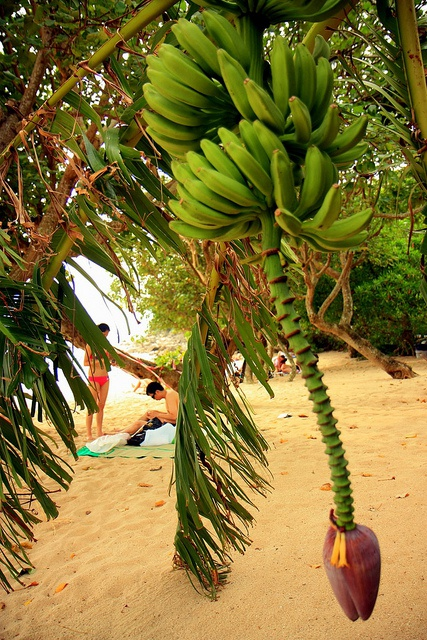Describe the objects in this image and their specific colors. I can see banana in black and olive tones, people in black, orange, red, and khaki tones, people in black, red, orange, and brown tones, people in black, tan, and red tones, and people in black, ivory, maroon, and olive tones in this image. 